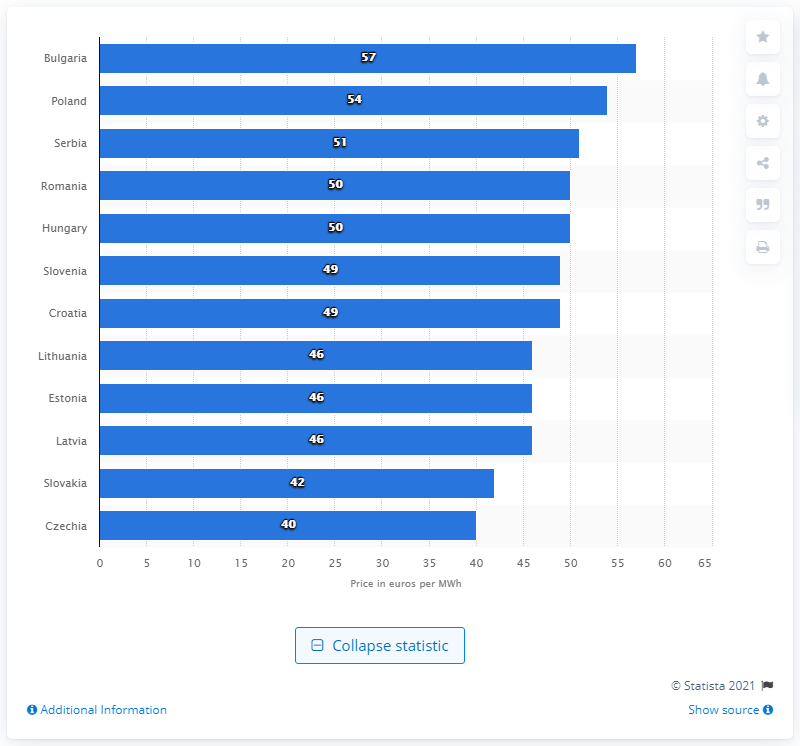Outline some significant characteristics in this image. Bulgaria had the highest wholesale prices of electricity in 2019, among all countries. 